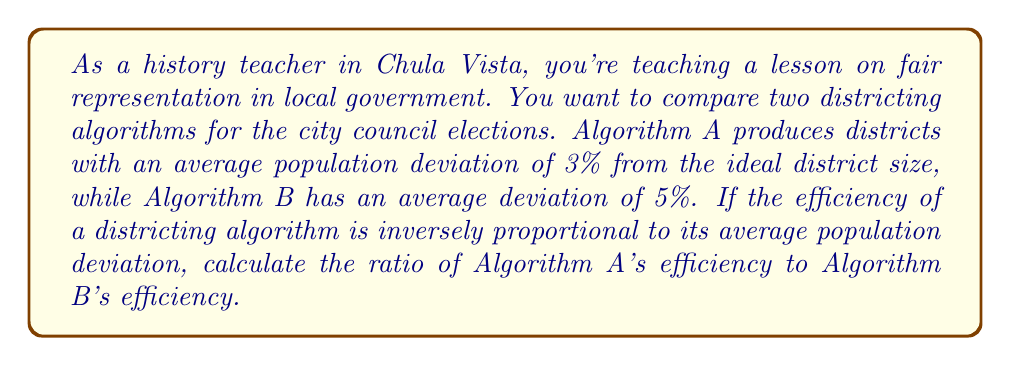Help me with this question. To solve this problem, we need to understand that the efficiency of the algorithm is inversely proportional to its average population deviation. This means that as the deviation increases, the efficiency decreases, and vice versa.

Let's define the efficiency of an algorithm as $E$ and the average population deviation as $d$. We can express the relationship as:

$$E \propto \frac{1}{d}$$

This means that for some constant $k$:

$$E = \frac{k}{d}$$

Now, let's define the efficiencies of Algorithm A and Algorithm B as $E_A$ and $E_B$ respectively:

$$E_A = \frac{k}{0.03}$$
$$E_B = \frac{k}{0.05}$$

To find the ratio of Algorithm A's efficiency to Algorithm B's efficiency, we divide $E_A$ by $E_B$:

$$\frac{E_A}{E_B} = \frac{\frac{k}{0.03}}{\frac{k}{0.05}}$$

The constant $k$ cancels out:

$$\frac{E_A}{E_B} = \frac{0.05}{0.03}$$

Now we can simplify this fraction:

$$\frac{E_A}{E_B} = \frac{5}{3}$$

This ratio indicates that Algorithm A is $\frac{5}{3}$ times more efficient than Algorithm B.
Answer: The ratio of Algorithm A's efficiency to Algorithm B's efficiency is $\frac{5}{3}$ or approximately 1.67. 